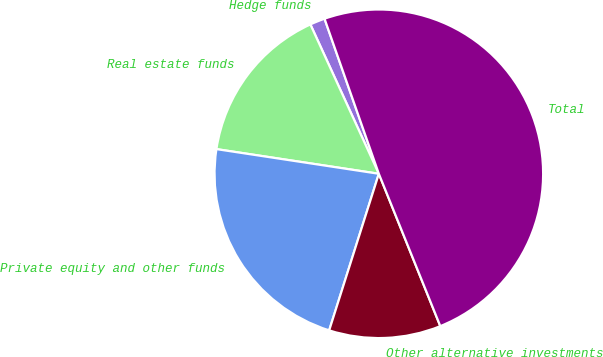Convert chart. <chart><loc_0><loc_0><loc_500><loc_500><pie_chart><fcel>Hedge funds<fcel>Real estate funds<fcel>Private equity and other funds<fcel>Other alternative investments<fcel>Total<nl><fcel>1.48%<fcel>15.76%<fcel>22.51%<fcel>10.99%<fcel>49.26%<nl></chart> 